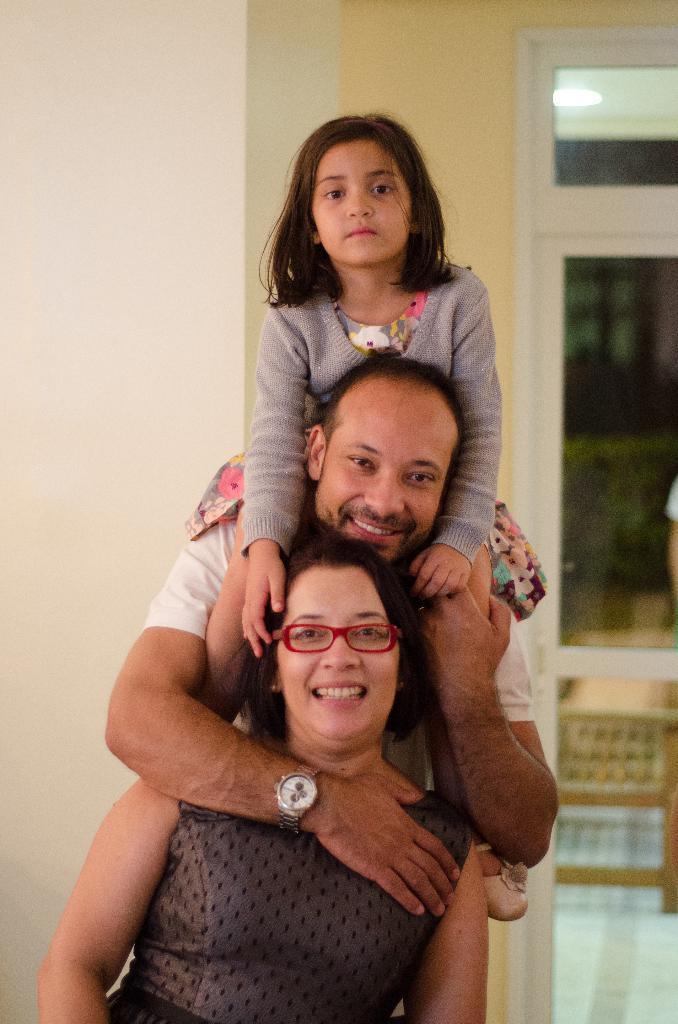Can you describe this image briefly? In this picture we can see a woman, a man and a girl, on the left side there is a wall, in the background we can see a chair, there is a glass door in the middle, we can see a light at the top of the picture. 